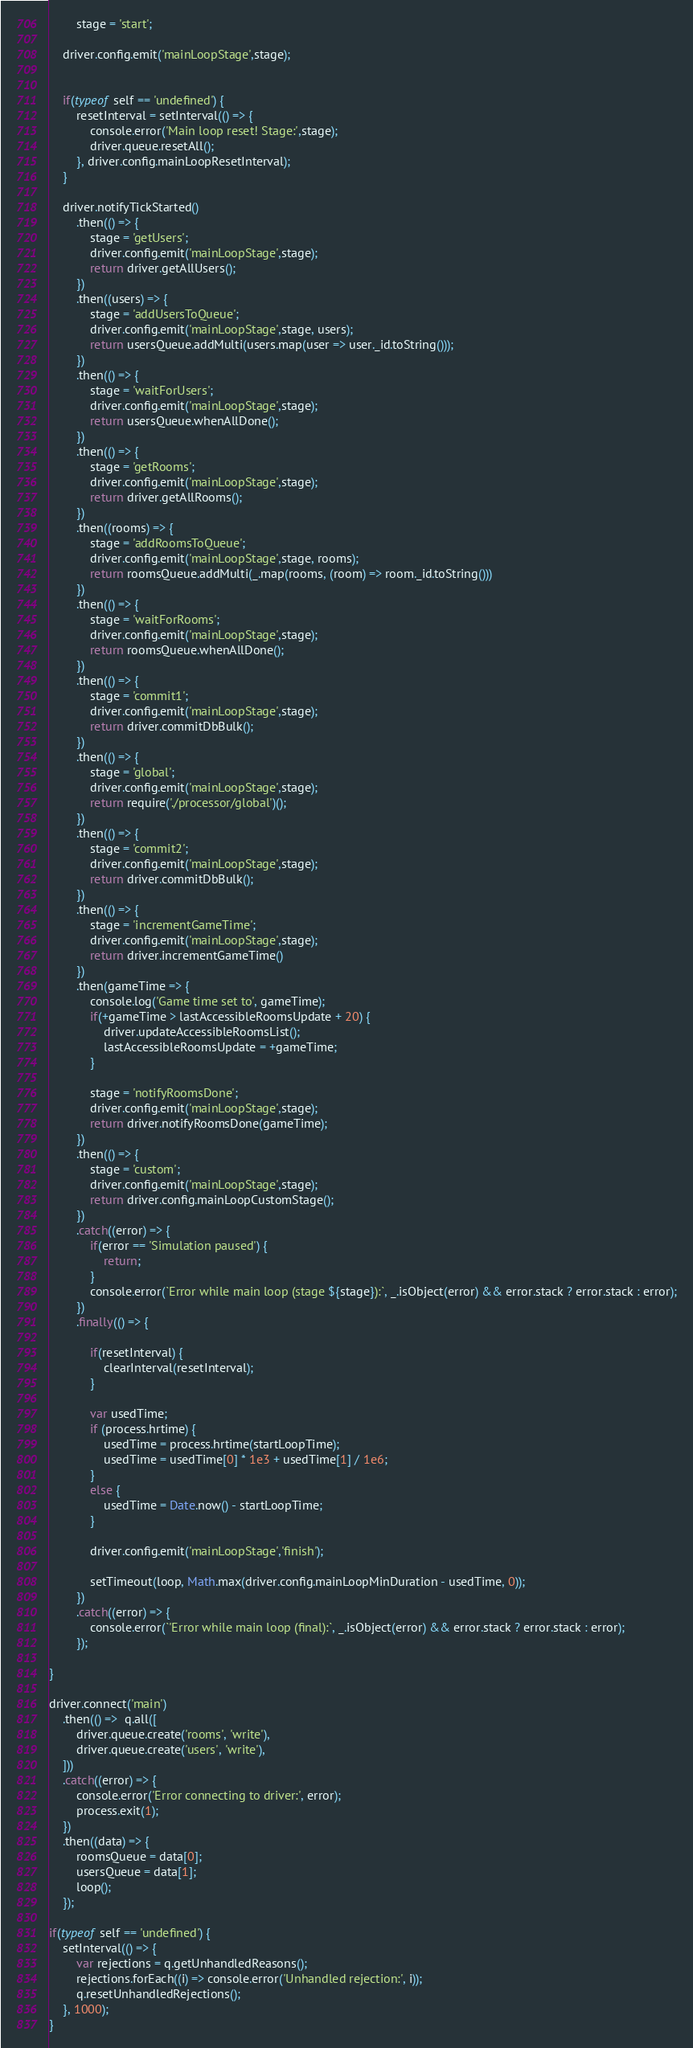<code> <loc_0><loc_0><loc_500><loc_500><_JavaScript_>        stage = 'start';

    driver.config.emit('mainLoopStage',stage);


    if(typeof self == 'undefined') {
        resetInterval = setInterval(() => {
            console.error('Main loop reset! Stage:',stage);
            driver.queue.resetAll();
        }, driver.config.mainLoopResetInterval);
    }

    driver.notifyTickStarted()
        .then(() => {
            stage = 'getUsers';
            driver.config.emit('mainLoopStage',stage);
            return driver.getAllUsers();
        })
        .then((users) => {
            stage = 'addUsersToQueue';
            driver.config.emit('mainLoopStage',stage, users);
            return usersQueue.addMulti(users.map(user => user._id.toString()));
        })
        .then(() => {
            stage = 'waitForUsers';
            driver.config.emit('mainLoopStage',stage);
            return usersQueue.whenAllDone();
        })
        .then(() => {
            stage = 'getRooms';
            driver.config.emit('mainLoopStage',stage);
            return driver.getAllRooms();
        })
        .then((rooms) => {
            stage = 'addRoomsToQueue';
            driver.config.emit('mainLoopStage',stage, rooms);
            return roomsQueue.addMulti(_.map(rooms, (room) => room._id.toString()))
        })
        .then(() => {
            stage = 'waitForRooms';
            driver.config.emit('mainLoopStage',stage);
            return roomsQueue.whenAllDone();
        })
        .then(() => {
            stage = 'commit1';
            driver.config.emit('mainLoopStage',stage);
            return driver.commitDbBulk();
        })
        .then(() => {
            stage = 'global';
            driver.config.emit('mainLoopStage',stage);
            return require('./processor/global')();
        })
        .then(() => {
            stage = 'commit2';
            driver.config.emit('mainLoopStage',stage);
            return driver.commitDbBulk();
        })
        .then(() => {
            stage = 'incrementGameTime';
            driver.config.emit('mainLoopStage',stage);
            return driver.incrementGameTime()
        })
        .then(gameTime => {
            console.log('Game time set to', gameTime);
            if(+gameTime > lastAccessibleRoomsUpdate + 20) {
                driver.updateAccessibleRoomsList();
                lastAccessibleRoomsUpdate = +gameTime;
            }

            stage = 'notifyRoomsDone';
            driver.config.emit('mainLoopStage',stage);
            return driver.notifyRoomsDone(gameTime);
        })
        .then(() => {
            stage = 'custom';
            driver.config.emit('mainLoopStage',stage);
            return driver.config.mainLoopCustomStage();
        })
        .catch((error) => {
            if(error == 'Simulation paused') {
                return;
            }
            console.error(`Error while main loop (stage ${stage}):`, _.isObject(error) && error.stack ? error.stack : error);
        })
        .finally(() => {

            if(resetInterval) {
                clearInterval(resetInterval);
            }

            var usedTime;
            if (process.hrtime) {
                usedTime = process.hrtime(startLoopTime);
                usedTime = usedTime[0] * 1e3 + usedTime[1] / 1e6;
            }
            else {
                usedTime = Date.now() - startLoopTime;
            }

            driver.config.emit('mainLoopStage','finish');

            setTimeout(loop, Math.max(driver.config.mainLoopMinDuration - usedTime, 0));
        })
        .catch((error) => {
            console.error(`'Error while main loop (final):`, _.isObject(error) && error.stack ? error.stack : error);
        });

}

driver.connect('main')
    .then(() =>  q.all([
        driver.queue.create('rooms', 'write'),
        driver.queue.create('users', 'write'),
    ]))
    .catch((error) => {
        console.error('Error connecting to driver:', error);
        process.exit(1);
    })
    .then((data) => {
        roomsQueue = data[0];
        usersQueue = data[1];
        loop();
    });

if(typeof self == 'undefined') {
    setInterval(() => {
        var rejections = q.getUnhandledReasons();
        rejections.forEach((i) => console.error('Unhandled rejection:', i));
        q.resetUnhandledRejections();
    }, 1000);
}</code> 